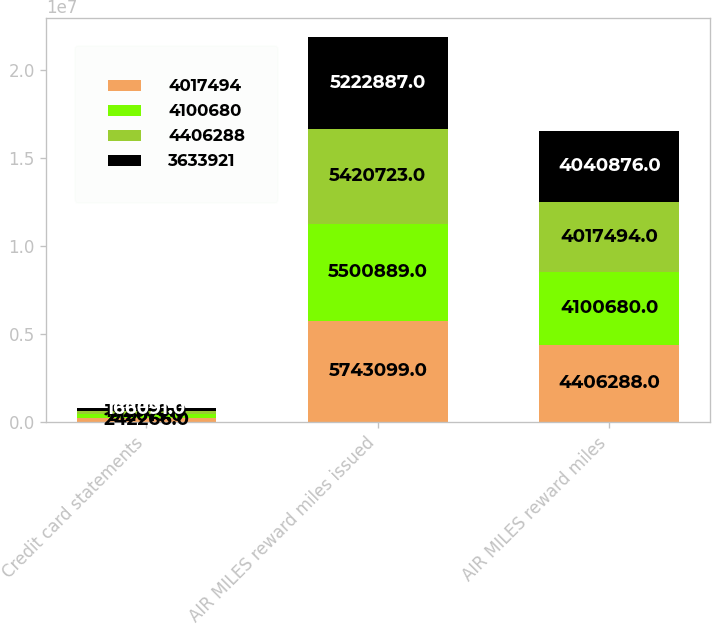Convert chart. <chart><loc_0><loc_0><loc_500><loc_500><stacked_bar_chart><ecel><fcel>Credit card statements<fcel>AIR MILES reward miles issued<fcel>AIR MILES reward miles<nl><fcel>4.01749e+06<fcel>242266<fcel>5.7431e+06<fcel>4.40629e+06<nl><fcel>4.10068e+06<fcel>212015<fcel>5.50089e+06<fcel>4.10068e+06<nl><fcel>4.40629e+06<fcel>192508<fcel>5.42072e+06<fcel>4.01749e+06<nl><fcel>3.63392e+06<fcel>166091<fcel>5.22289e+06<fcel>4.04088e+06<nl></chart> 